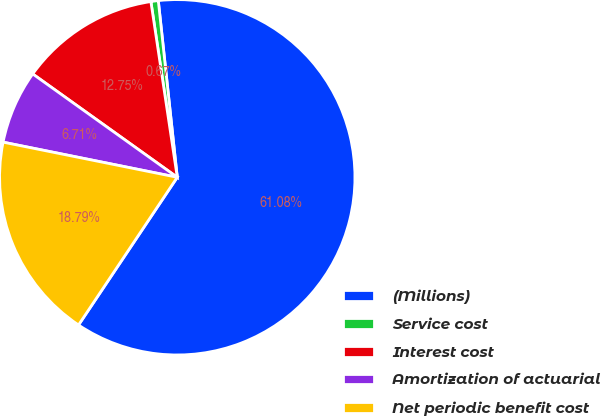Convert chart. <chart><loc_0><loc_0><loc_500><loc_500><pie_chart><fcel>(Millions)<fcel>Service cost<fcel>Interest cost<fcel>Amortization of actuarial<fcel>Net periodic benefit cost<nl><fcel>61.08%<fcel>0.67%<fcel>12.75%<fcel>6.71%<fcel>18.79%<nl></chart> 